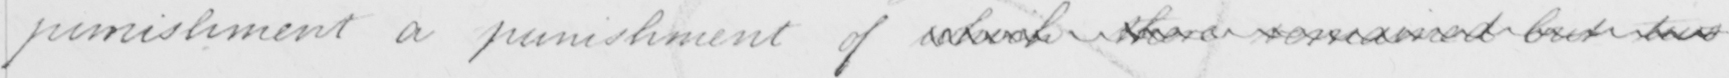What does this handwritten line say? punishment a punishment of which there remained but two 